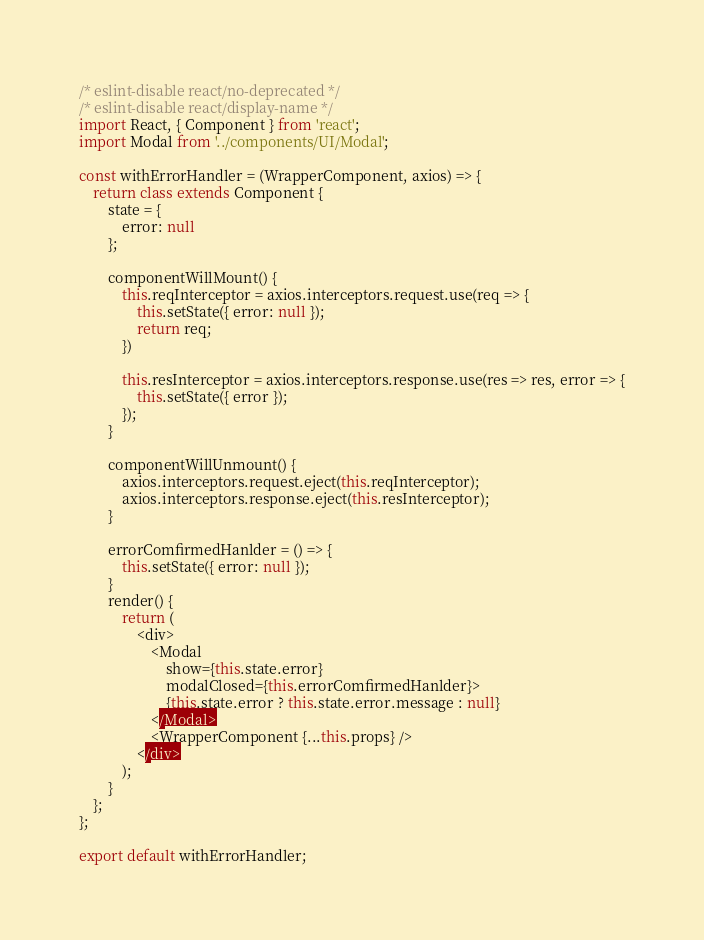<code> <loc_0><loc_0><loc_500><loc_500><_JavaScript_>/* eslint-disable react/no-deprecated */
/* eslint-disable react/display-name */
import React, { Component } from 'react';
import Modal from '../components/UI/Modal';

const withErrorHandler = (WrapperComponent, axios) => {
    return class extends Component {
        state = {
            error: null
        };

        componentWillMount() {
            this.reqInterceptor = axios.interceptors.request.use(req => {
                this.setState({ error: null });
                return req;
            })

            this.resInterceptor = axios.interceptors.response.use(res => res, error => {
                this.setState({ error });
            });
        }

        componentWillUnmount() {
            axios.interceptors.request.eject(this.reqInterceptor);
            axios.interceptors.response.eject(this.resInterceptor);
        }

        errorComfirmedHanlder = () => {
            this.setState({ error: null });
        }
        render() {
            return (
                <div>
                    <Modal
                        show={this.state.error}
                        modalClosed={this.errorComfirmedHanlder}>
                        {this.state.error ? this.state.error.message : null}
                    </Modal>
                    <WrapperComponent {...this.props} />
                </div>
            );
        }
    };
};

export default withErrorHandler;</code> 